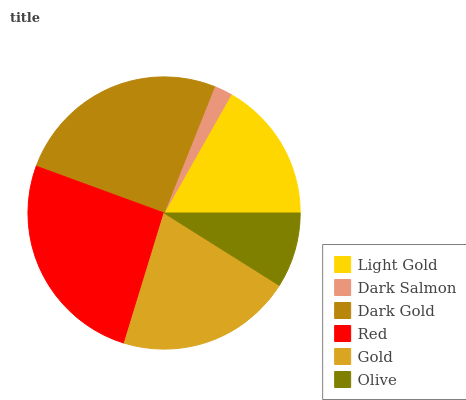Is Dark Salmon the minimum?
Answer yes or no. Yes. Is Red the maximum?
Answer yes or no. Yes. Is Dark Gold the minimum?
Answer yes or no. No. Is Dark Gold the maximum?
Answer yes or no. No. Is Dark Gold greater than Dark Salmon?
Answer yes or no. Yes. Is Dark Salmon less than Dark Gold?
Answer yes or no. Yes. Is Dark Salmon greater than Dark Gold?
Answer yes or no. No. Is Dark Gold less than Dark Salmon?
Answer yes or no. No. Is Gold the high median?
Answer yes or no. Yes. Is Light Gold the low median?
Answer yes or no. Yes. Is Red the high median?
Answer yes or no. No. Is Olive the low median?
Answer yes or no. No. 